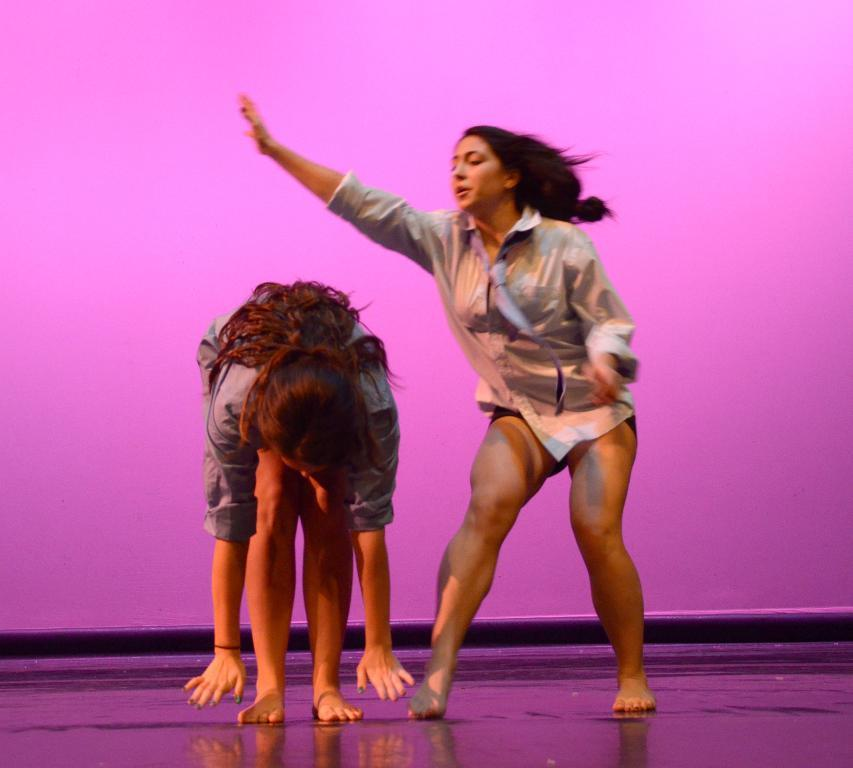How many people are in the image? There are two women in the image. What is located behind the women in the image? There is a wall behind the women in the image. What type of birth can be seen happening in the image? There is no birth depicted in the image; it features two women and a wall. What scientific theory is being discussed by the women in the image? There is no indication of a scientific discussion or theory in the image. 